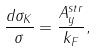Convert formula to latex. <formula><loc_0><loc_0><loc_500><loc_500>\frac { d \sigma _ { K } } { \sigma } = \frac { A _ { y } ^ { s t r } } { k _ { F } } ,</formula> 